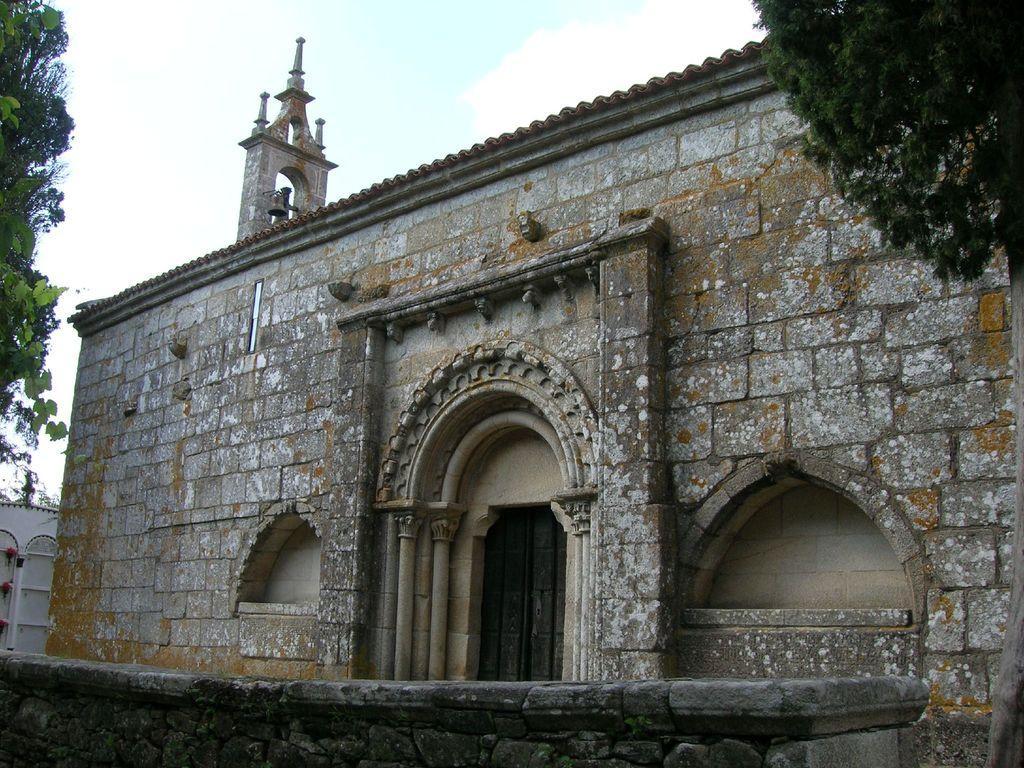How would you summarize this image in a sentence or two? In the center of the image there is a building. On the right side there is a tree. On the left side there is a tree. In the background we can see sky and clouds. At the bottom there is a wall. 